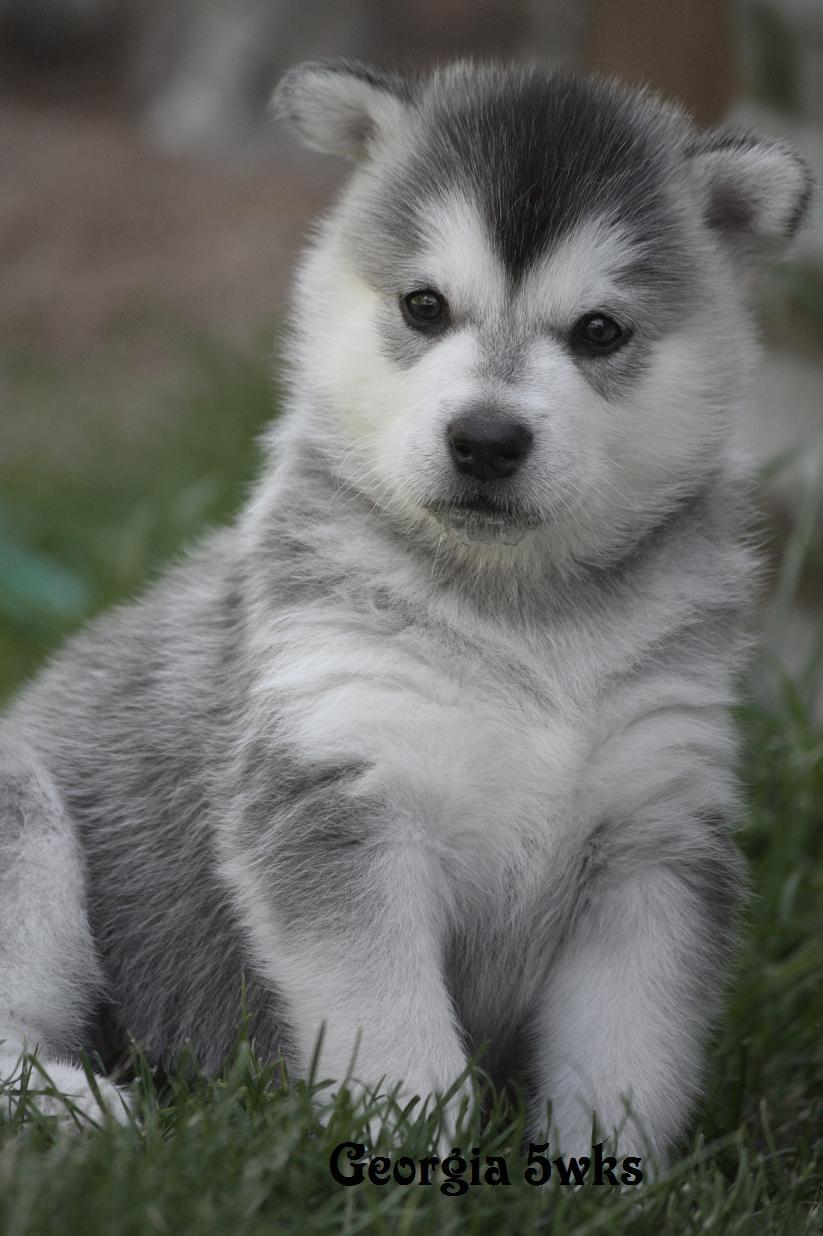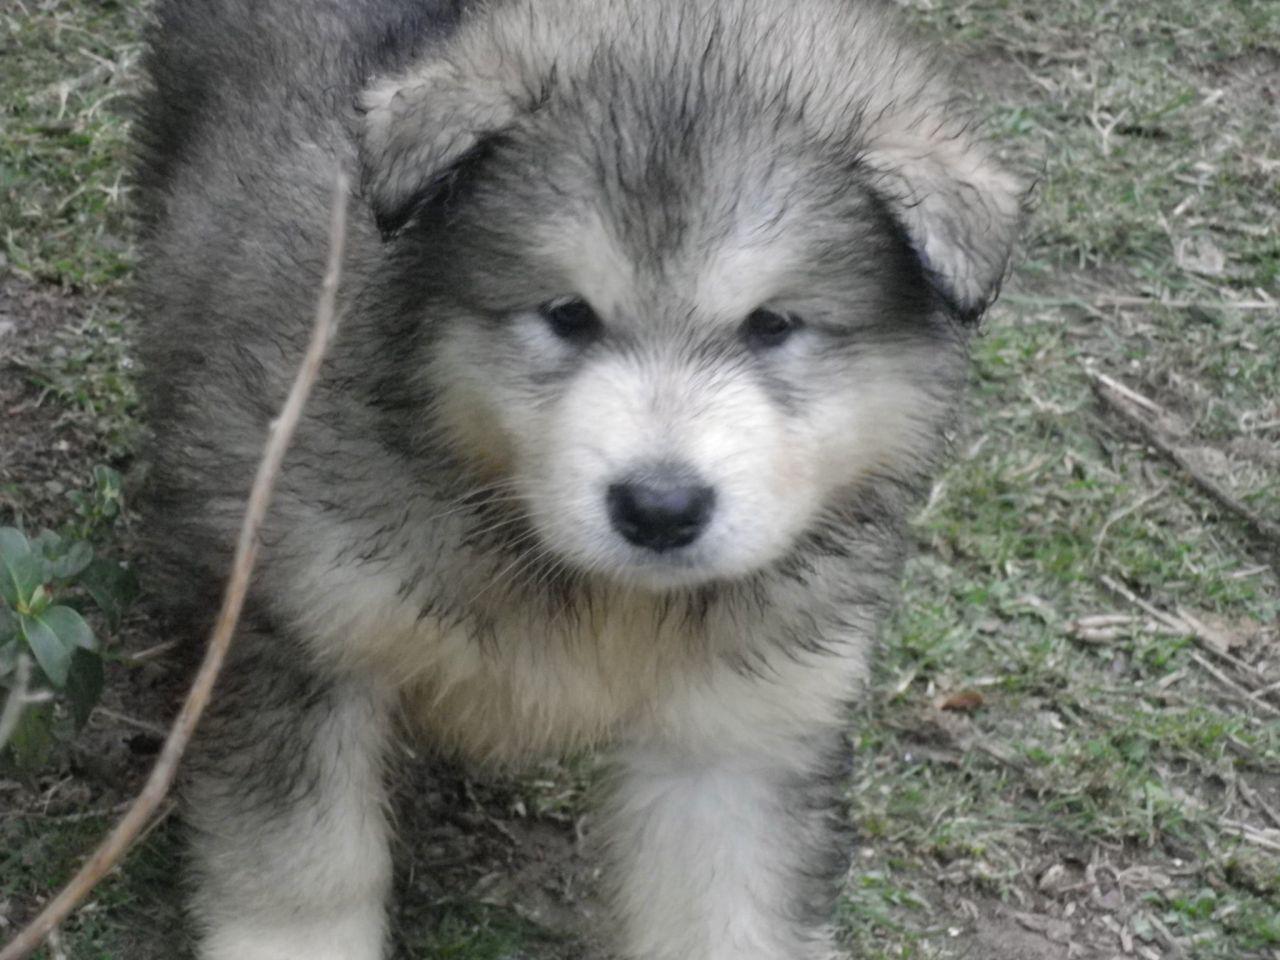The first image is the image on the left, the second image is the image on the right. Evaluate the accuracy of this statement regarding the images: "There is a puppy and an adult dog". Is it true? Answer yes or no. No. The first image is the image on the left, the second image is the image on the right. For the images displayed, is the sentence "One image shows a gray-and-white husky puppy sitting upright, and the other image shows a darker adult husky with its mouth open." factually correct? Answer yes or no. No. 